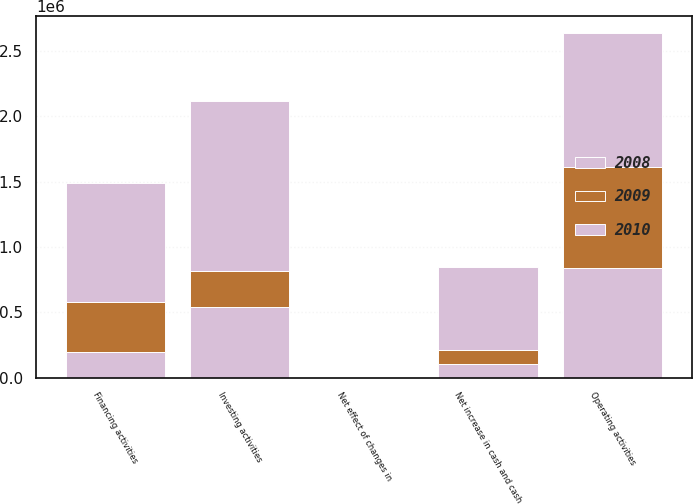Convert chart to OTSL. <chart><loc_0><loc_0><loc_500><loc_500><stacked_bar_chart><ecel><fcel>Operating activities<fcel>Investing activities<fcel>Financing activities<fcel>Net effect of changes in<fcel>Net increase in cash and cash<nl><fcel>2010<fcel>1.02098e+06<fcel>1.3009e+06<fcel>910330<fcel>6265<fcel>636670<nl><fcel>2008<fcel>842126<fcel>543066<fcel>194942<fcel>98<fcel>104216<nl><fcel>2009<fcel>773258<fcel>274940<fcel>388172<fcel>192<fcel>109954<nl></chart> 